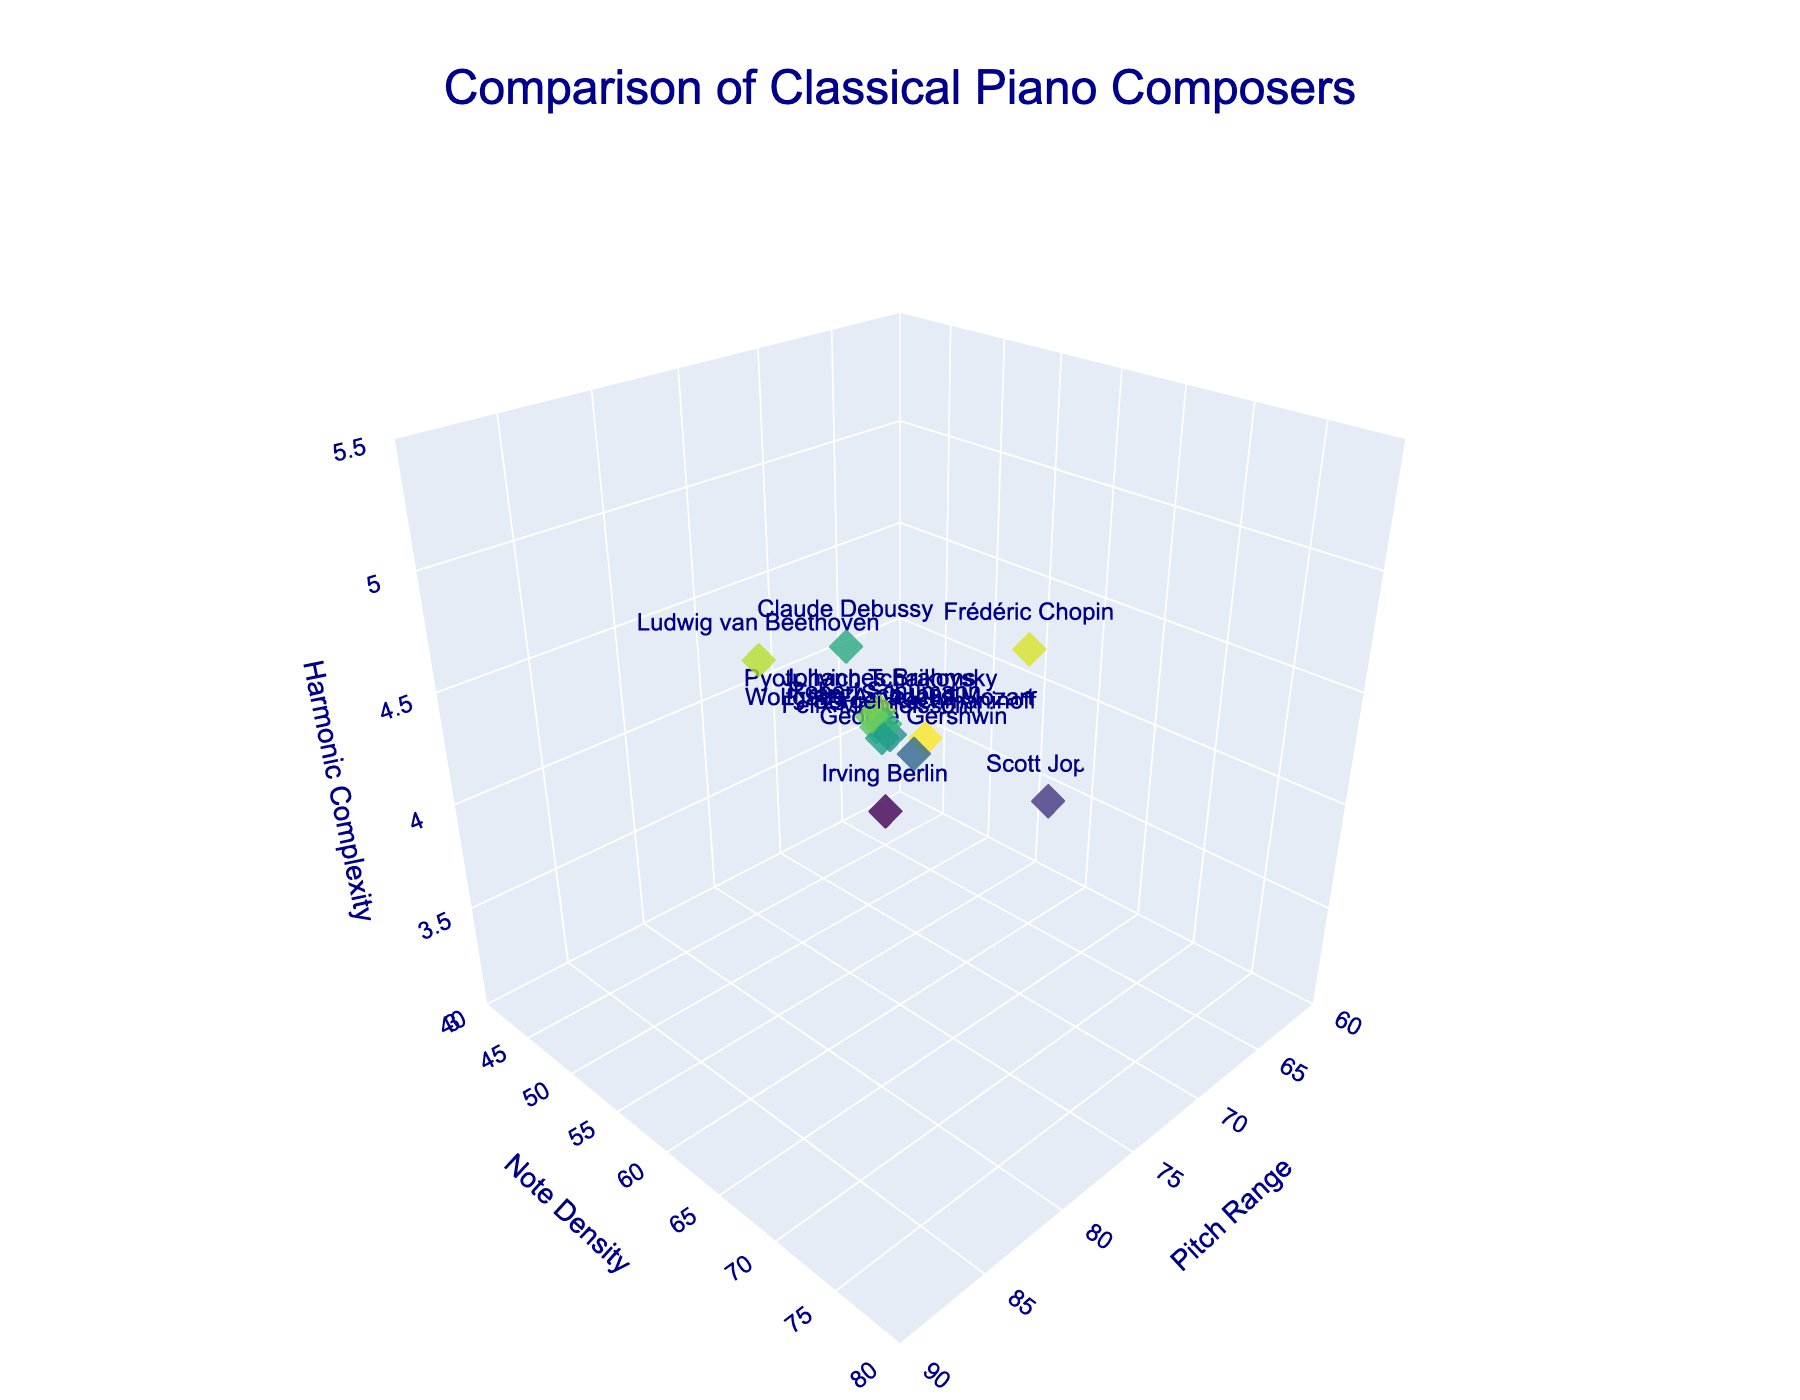What is the title of the plot? The title of the plot is prominently displayed at the top center of the figure. It reads "Comparison of Classical Piano Composers," which summarizes the focus of the plot.
Answer: Comparison of Classical Piano Composers Which composer has the highest pitch range? By looking at the x-axis labeled "Pitch Range," we can observe which data point is plotted furthest along this axis. The point furthest to the right is Sergei Rachmaninoff with a pitch range of 85.
Answer: Sergei Rachmaninoff How many composers have a note density greater than 60? By looking at the y-axis labeled "Note Density," you can count the number of data points above the 60 mark. These composers are Frédéric Chopin, Sergei Rachmaninoff, Johannes Brahms, Franz Schubert, and Pyotr Ilyich Tchaikovsky.
Answer: 5 Which composer has the lowest harmonic complexity? By examining the z-axis labeled "Harmonic Complexity," the composer with the lowest value is Scott Joplin, with a complexity of 3.5.
Answer: Scott Joplin What is the range of harmonic complexity values present in the plot? To find the range, we need to identify the minimum and maximum values on the z-axis. The minimum is 3.2 (Irving Berlin) and the maximum is 5.0 (Sergei Rachmaninoff). The range is calculated as 5.0 - 3.2.
Answer: 1.8 Compare the note density of Frédéric Chopin and George Gershwin. Who has the higher note density, and by how much? From the plot, Frédéric Chopin has a note density of 70, and George Gershwin has 52. The difference is 70 - 52. Therefore, Frédéric Chopin has a higher note density by 18.
Answer: Frédéric Chopin by 18 Which composer is closest in all three dimensions (Pitch Range, Note Density, and Harmonic Complexity) to Johannes Brahms? Johannes Brahms has values of 80, 65, and 4.7 for pitch range, note density, and harmonic complexity, respectively. Pyotr Ilyich Tchaikovsky's values (79, 63, 4.6) are closest across all three dimensions.
Answer: Pyotr Ilyich Tchaikovsky What is the average harmonic complexity of the composers whose pitch range is above 75? The composers with a pitch range above 75 are Franz Schubert, Ludwig van Beethoven, Frédéric Chopin, Johannes Brahms, Sergei Rachmaninoff, Robert Schumann, and Pyotr Ilyich Tchaikovsky. Their harmonic complexities are 4.5, 4.8, 4.9, 4.7, 5.0, 4.4, and 4.6 respectively. The average is calculated as (4.5+4.8+4.9+4.7+5.0+4.4+4.6)/7.
Answer: 4.70 Which composer has a note density closest to the median note density of all composers? To determine this, first list the note densities: 45, 62, 58, 70, 55, 65, 48, 75, 60, 52, 58, 57, 63. The median of these values is 58. Robert Schumann and Scott Joplin both have note densities of 58, which is the median value.
Answer: Robert Schumann and Scott Joplin 